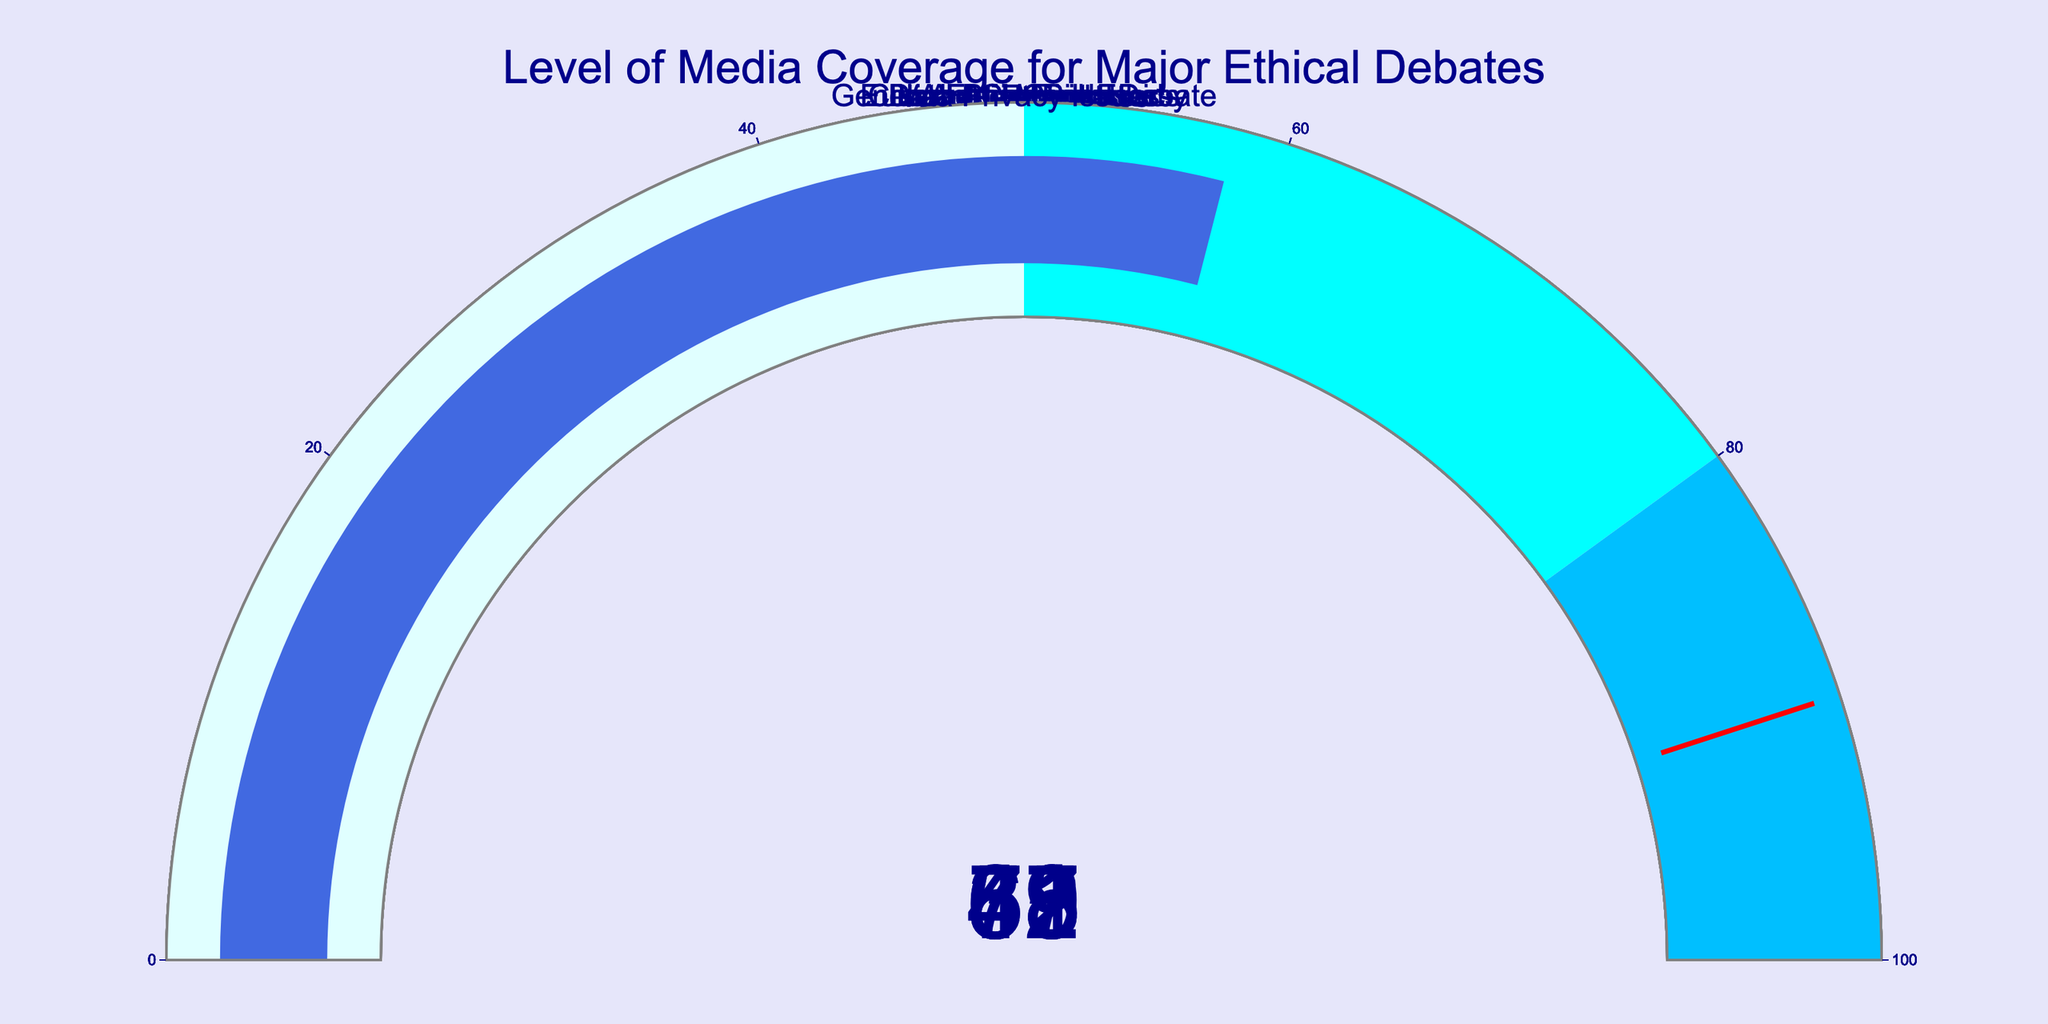what is the topic with the highest coverage percentage? The figure shows different gauge charts with coverage percentages. By comparing these values, we find Abortion Rights with 78% has the highest coverage percentage.
Answer: Abortion Rights what is the total coverage percentage of Climate Change Ethics and AI Ethics combined? The coverage percentages for Climate Change Ethics and AI Ethics are 62% and 45%, respectively. Adding these values gives us 62 + 45 = 107%.
Answer: 107% which topic has the lowest coverage percentage? By examining the gauge charts, Animal Rights has the lowest coverage percentage at 31%.
Answer: Animal Rights how much more media coverage does Vaccine Mandates have compared to Data Privacy Issues? The coverage percentages are 67% for Vaccine Mandates and 58% for Data Privacy Issues. The difference is 67 - 58 = 9%.
Answer: 9% what is the average coverage percentage of all topics displayed? The coverage percentages are 78, 62, 45, 53, 39, 31, 67, 58. Summing them up gives 433. There are 8 topics, so the average is 433 / 8 = 54.125%.
Answer: 54.125% how many topics have coverage percentages above 50%? The topics with coverage percentages above 50% are Abortion Rights (78%), Climate Change Ethics (62%), Vaccine Mandates (67%), and Data Privacy Issues (58%). There are 4 such topics.
Answer: 4 which topics have the same threshold color on their gauge and what is this color? The threshold color appears as a red line. The gauges for all topics have the same red threshold line indicating a value of 90.
Answer: All topics have red as their threshold color what is the median coverage percentage of all topics? Ordering the percentages: 31, 39, 45, 53, 58, 62, 67, 78. The median is the average of the middle two values (53 and 58). Thus, (53 + 58) / 2 = 55.5%.
Answer: 55.5% which topic falls into the same colored step range as Data Privacy Issues? Data Privacy Issues has a coverage of 58%, which falls in the cyan color range (50-80). Other topics in this range are Climate Change Ethics (62%) and Vaccine Mandates (67%).
Answer: Climate Change Ethics, Vaccine Mandates how many topics are represented in the color lightcyan on their gauges? The lightcyan color represents the range 0-50. The topics in this range are AI Ethics (45%), Genetic Engineering Debate (53%), Euthanasia Controversy (39%), and Animal Rights (31%).
Answer: 4 